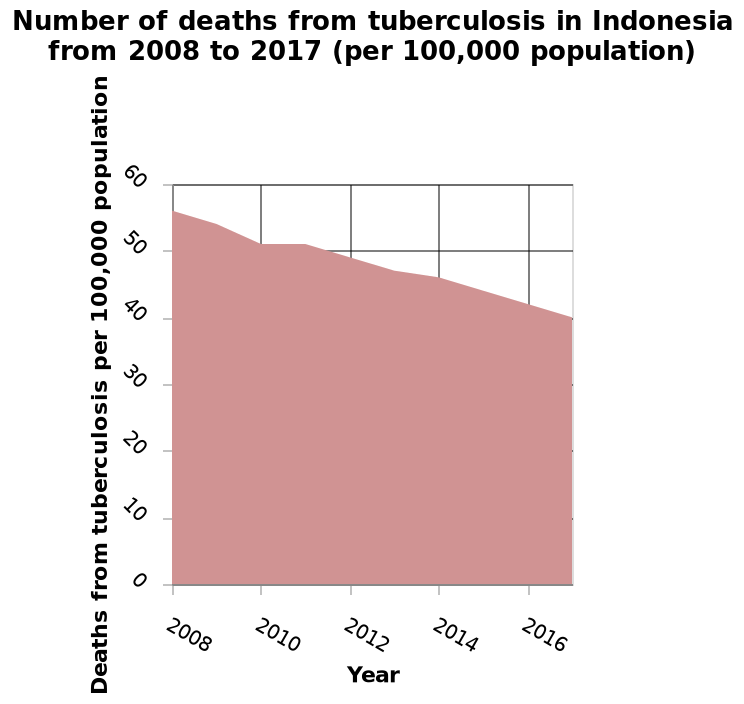<image>
What was the age range of deaths in 2008? The description does not provide information about the specific age range of deaths in 2008. Offer a thorough analysis of the image. The age range of deaths reduced from over 60s to over 40s in 2016. the overall number of deaths has reduced over the length of the study i.e., from 2008.Overall the main deaths during the whole of the study have been in the under 40s. What is shown on the y-axis and what is the scale? The y-axis represents the number of deaths from tuberculosis per 100,000 population, and it is drawn with a linear scale ranging from 0 to 60. Which age group had the highest number of deaths throughout the entire study? Overall, the main deaths during the whole of the study have been in the under 40s. What is the range of values shown on the y-axis? The y-axis ranges from 0 to 60, representing the number of deaths from tuberculosis per 100,000 population. 